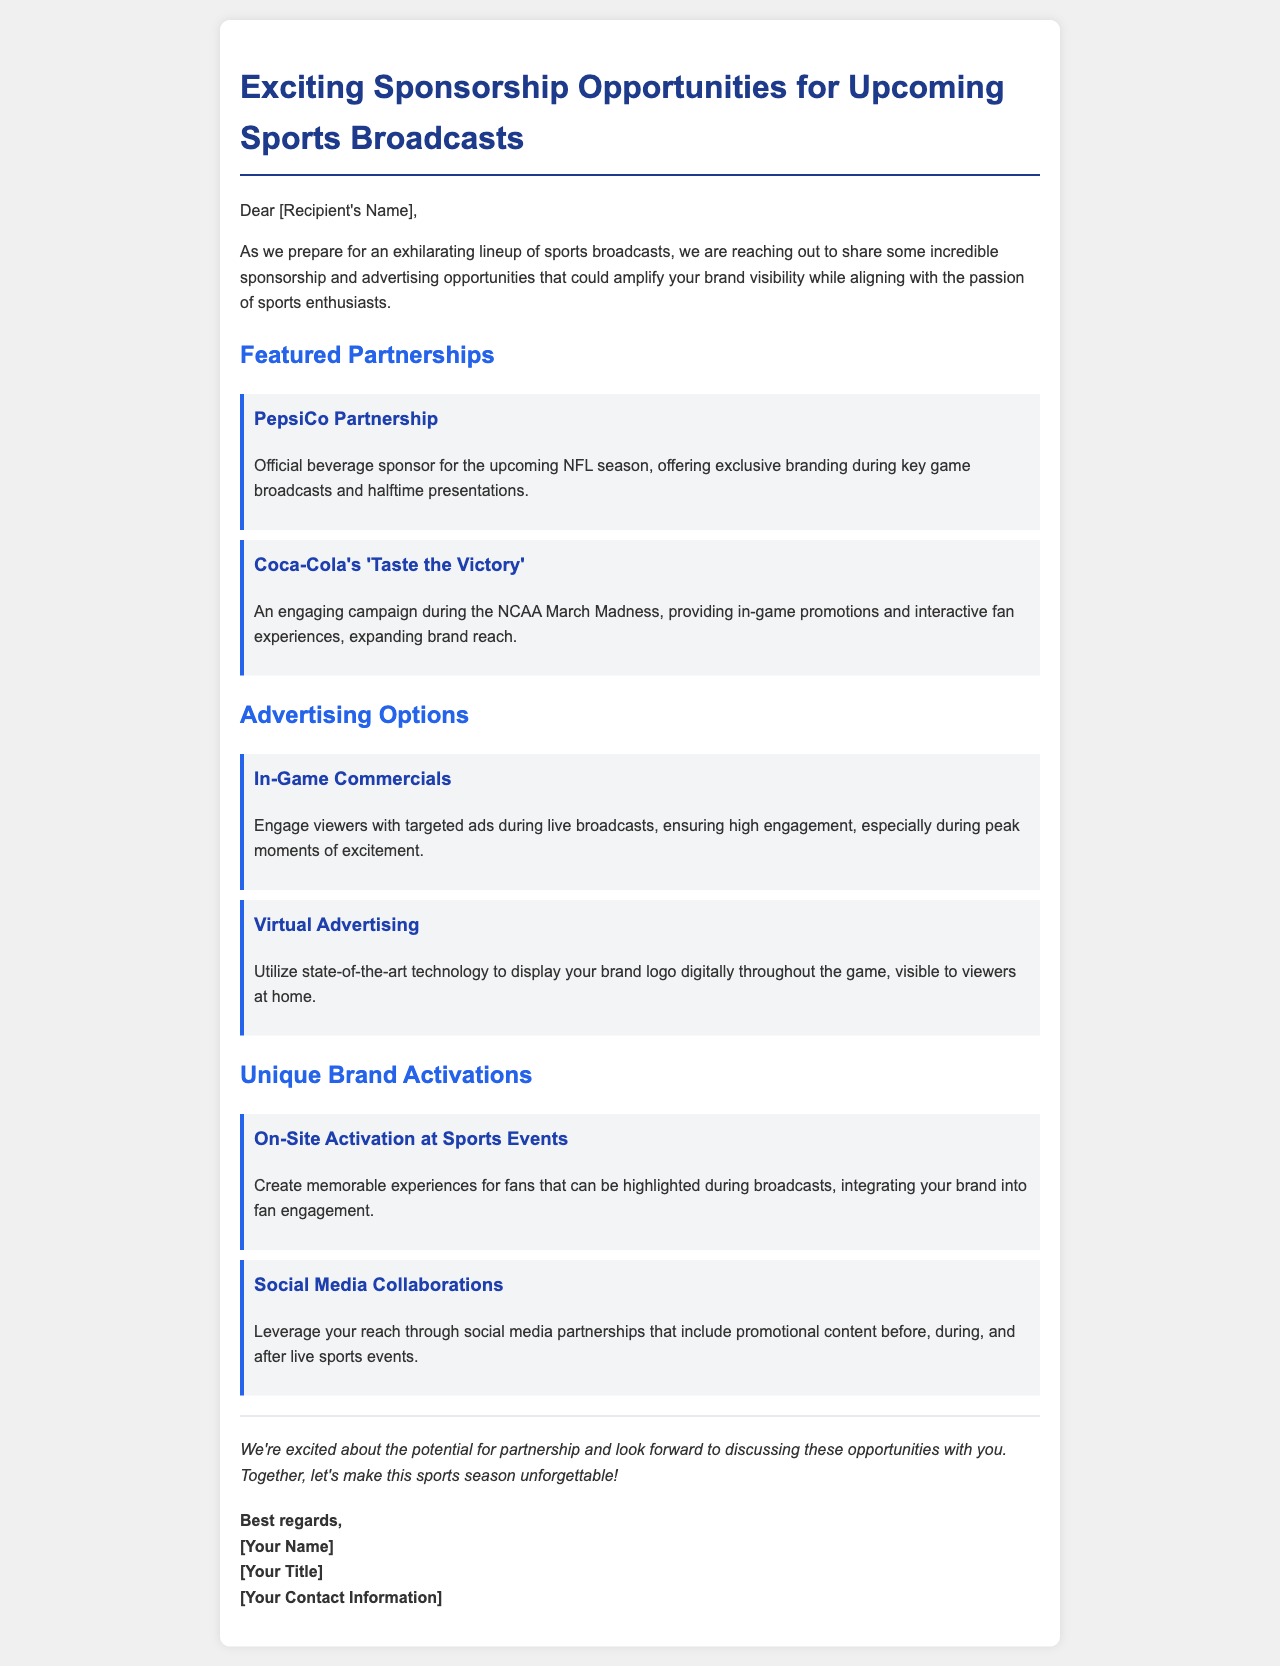What is the title of the email? The title of the email is stated at the top of the document.
Answer: Exciting Sponsorship Opportunities for Upcoming Sports Broadcasts Who is the official beverage sponsor for the upcoming NFL season? This information is found in the Featured Partnerships section of the document.
Answer: PepsiCo Partnership What campaign does Coca-Cola have during NCAA March Madness? The campaign name is listed under the Featured Partnerships section.
Answer: 'Taste the Victory' What type of advertising option is mentioned that utilizes state-of-the-art technology? The document describes this option under the Advertising Options section.
Answer: Virtual Advertising What type of on-site activity is suggested for brand activation? This information is found in the Unique Brand Activations section of the document.
Answer: On-Site Activation at Sports Events How many Featured Partnerships are listed in the email? This involves counting the number of items in the section.
Answer: Two 